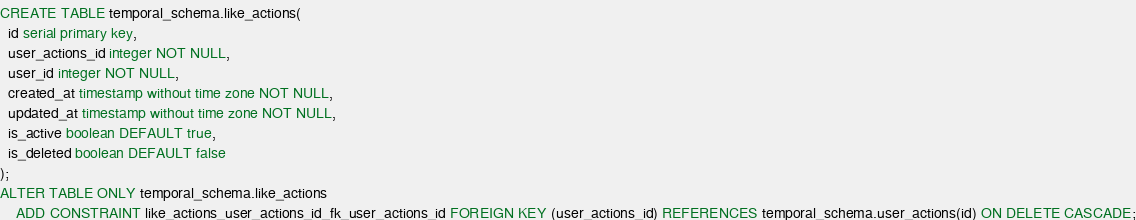<code> <loc_0><loc_0><loc_500><loc_500><_SQL_>CREATE TABLE temporal_schema.like_actions(
  id serial primary key,
  user_actions_id integer NOT NULL,
  user_id integer NOT NULL,
  created_at timestamp without time zone NOT NULL,
  updated_at timestamp without time zone NOT NULL,
  is_active boolean DEFAULT true,
  is_deleted boolean DEFAULT false
);
ALTER TABLE ONLY temporal_schema.like_actions
    ADD CONSTRAINT like_actions_user_actions_id_fk_user_actions_id FOREIGN KEY (user_actions_id) REFERENCES temporal_schema.user_actions(id) ON DELETE CASCADE;</code> 